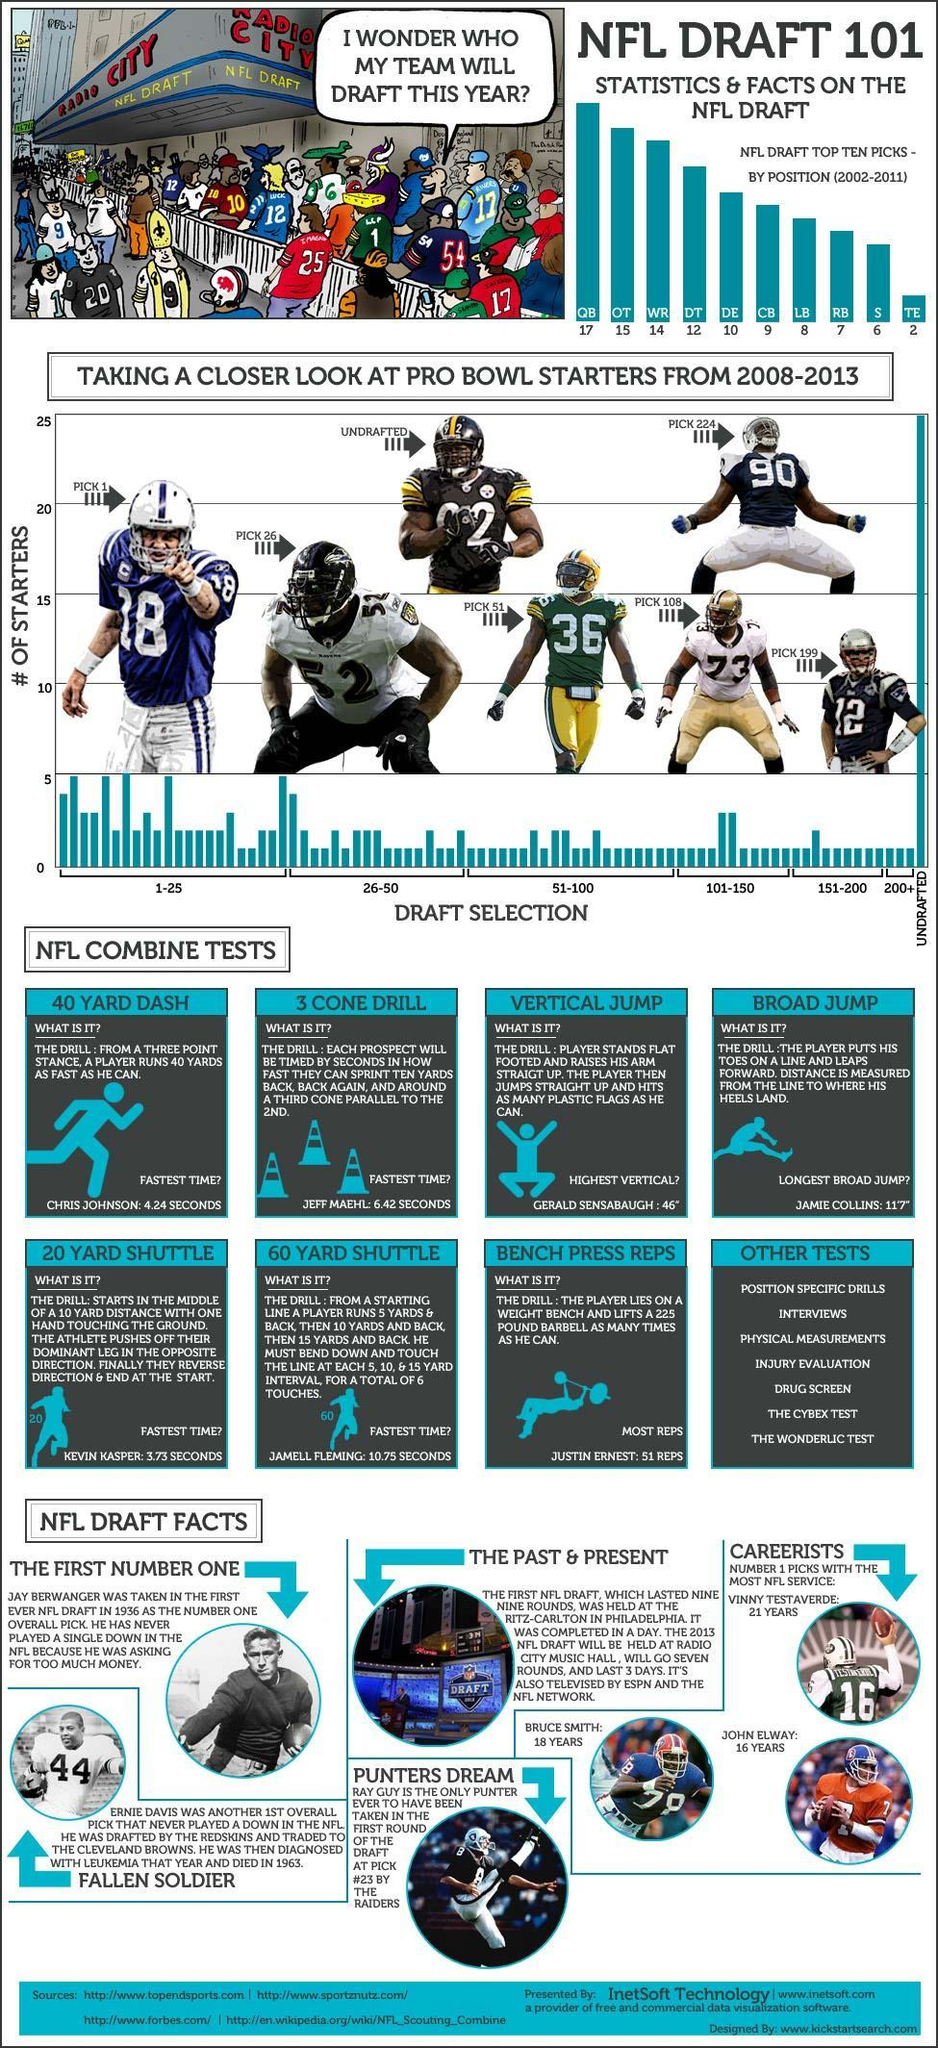Which are the players with the most NFL service?
Answer the question with a short phrase. Vinny Test Averde, Bruce Smith, John Elway What is the name of the player with jersey number 8? Ray Guy What is the jersey number of the player who appears as pick number fifty one? 36 What is the pick number of the player with jersey number 90? 224 What was the fastest time recorded for 20 yard shuttle, 10.75 seconds, 6.42 seconds or 3.73 seconds? 3.73 seconds Who scored the fastest time in 60 yard shuttle? Jamell Fleming How many tests are listed in other tests? 7 What is the name of the player with jersey number 16? Vinny Test Averde What is the number on the helmet of the player who has been listed as undrafted? 92 